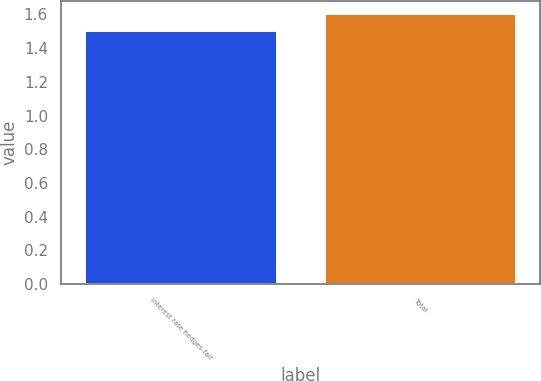Convert chart to OTSL. <chart><loc_0><loc_0><loc_500><loc_500><bar_chart><fcel>Interest rate hedges-fair<fcel>Total<nl><fcel>1.5<fcel>1.6<nl></chart> 